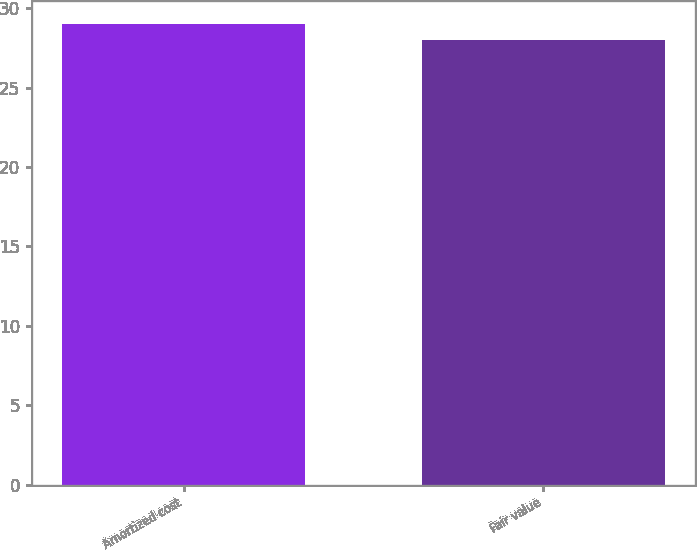<chart> <loc_0><loc_0><loc_500><loc_500><bar_chart><fcel>Amortized cost<fcel>Fair value<nl><fcel>29<fcel>28<nl></chart> 